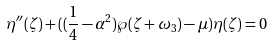<formula> <loc_0><loc_0><loc_500><loc_500>\eta ^ { \prime \prime } ( \zeta ) + ( ( \frac { 1 } { 4 } - \alpha ^ { 2 } ) \wp ( \zeta + \omega _ { 3 } ) - \mu ) \eta ( \zeta ) = 0</formula> 